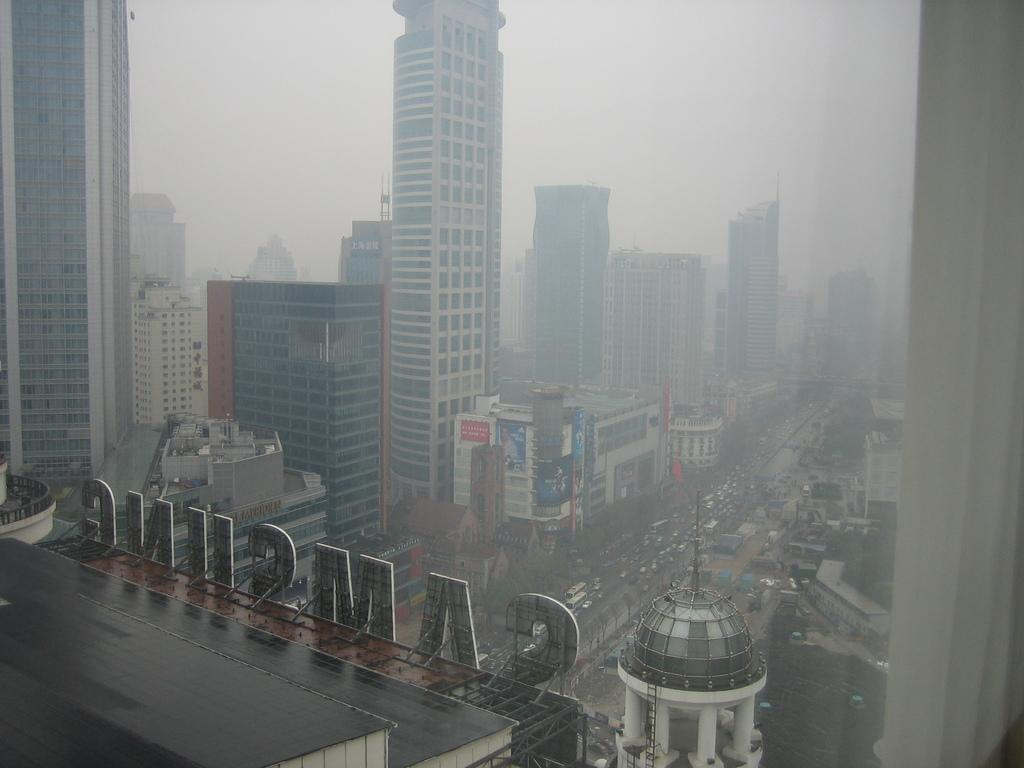What type of structures can be seen in the image? There are buildings in the image. What else can be seen on the ground in the image? There are vehicles on the road in the image. What part of the natural environment is visible in the image? The sky is visible in the background of the image. What type of pollution can be seen coming from the buildings in the image? There is no indication of pollution in the image; it only shows buildings, vehicles, and the sky. 